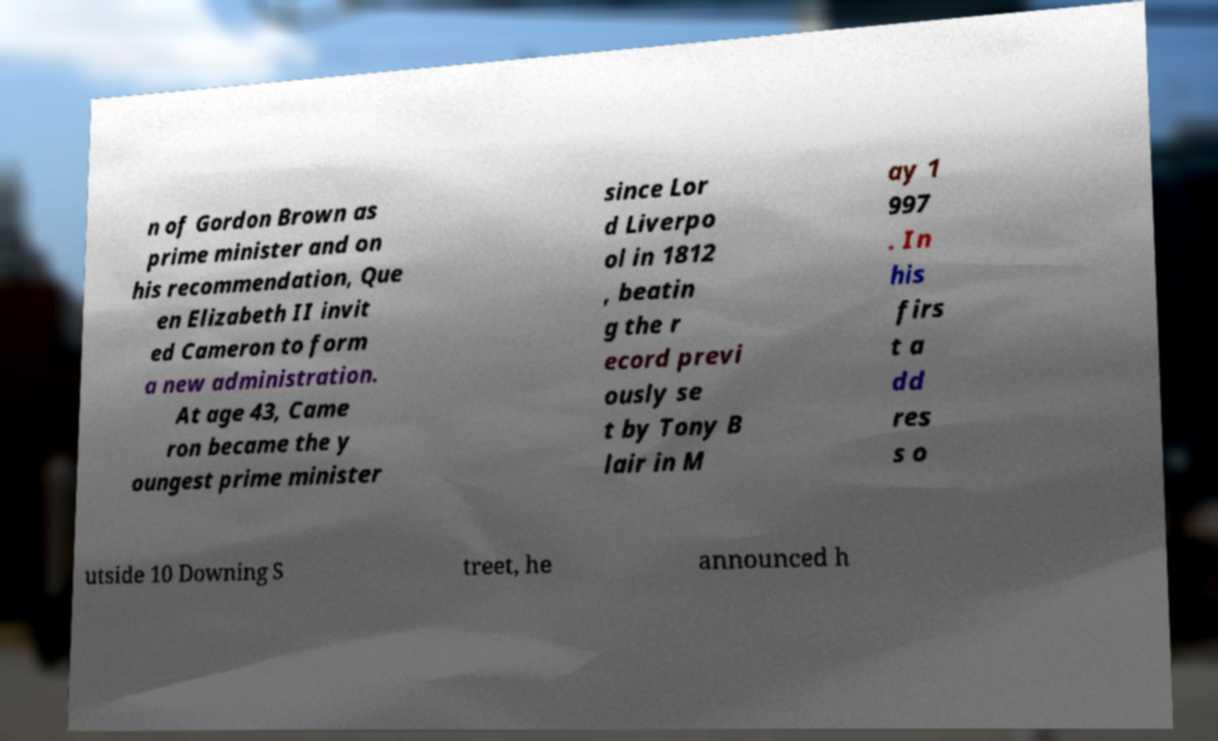Could you extract and type out the text from this image? n of Gordon Brown as prime minister and on his recommendation, Que en Elizabeth II invit ed Cameron to form a new administration. At age 43, Came ron became the y oungest prime minister since Lor d Liverpo ol in 1812 , beatin g the r ecord previ ously se t by Tony B lair in M ay 1 997 . In his firs t a dd res s o utside 10 Downing S treet, he announced h 